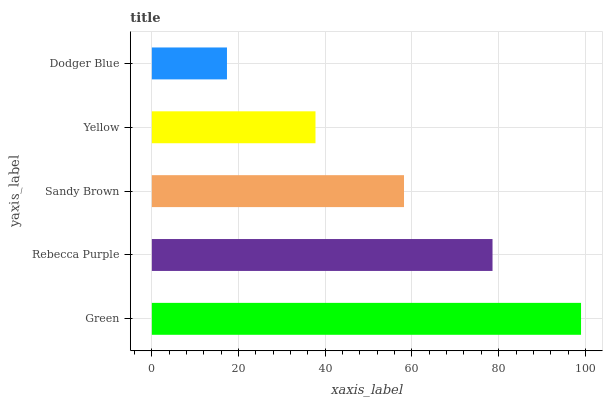Is Dodger Blue the minimum?
Answer yes or no. Yes. Is Green the maximum?
Answer yes or no. Yes. Is Rebecca Purple the minimum?
Answer yes or no. No. Is Rebecca Purple the maximum?
Answer yes or no. No. Is Green greater than Rebecca Purple?
Answer yes or no. Yes. Is Rebecca Purple less than Green?
Answer yes or no. Yes. Is Rebecca Purple greater than Green?
Answer yes or no. No. Is Green less than Rebecca Purple?
Answer yes or no. No. Is Sandy Brown the high median?
Answer yes or no. Yes. Is Sandy Brown the low median?
Answer yes or no. Yes. Is Rebecca Purple the high median?
Answer yes or no. No. Is Rebecca Purple the low median?
Answer yes or no. No. 